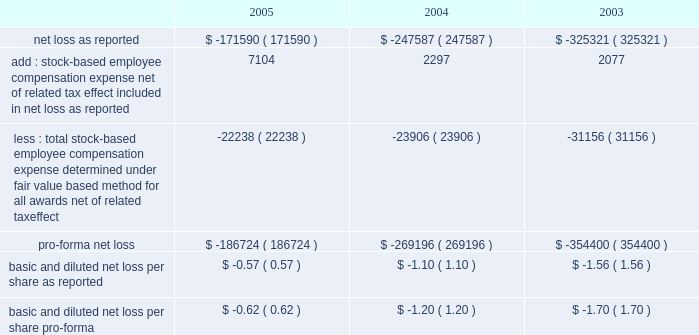American tower corporation and subsidiaries notes to consolidated financial statements 2014 ( continued ) sfas no .
148 .
In accordance with apb no .
25 , the company recognizes compensation expense based on the excess , if any , of the quoted stock price at the grant date of the award or other measurement date over the amount an employee must pay to acquire the stock .
The company 2019s stock option plans are more fully described in note 14 .
In december 2004 , the fasb issued sfas no .
123 ( revised 2004 ) , 201cshare-based payment 201d ( sfas 123r ) , as further described below .
During the year ended december 31 , 2005 , the company reevaluated the assumptions used to estimate the fair value of stock options issued to employees .
As a result , the company lowered its expected volatility assumption for options granted after july 1 , 2005 to approximately 30% ( 30 % ) and increased the expected life of option grants to 6.25 years using the simplified method permitted by sec sab no .
107 , 201dshare-based payment 201d ( sab no .
107 ) .
The company made this change based on a number of factors , including the company 2019s execution of its strategic plans to sell non-core businesses , reduce leverage and refinance its debt , and its recent merger with spectrasite , inc .
( see note 2. ) management had previously based its volatility assumptions on historical volatility since inception , which included periods when the company 2019s capital structure was more highly leveraged than current levels and expected levels for the foreseeable future .
Management 2019s estimate of future volatility is based on its consideration of all available information , including historical volatility , implied volatility of publicly traded options , the company 2019s current capital structure and its publicly announced future business plans .
For comparative purposes , a 10% ( 10 % ) change in the volatility assumption would change pro forma stock option expense and pro forma net loss by approximately $ 0.1 million for the year ended december 31 , 2005 .
( see note 14. ) the table illustrates the effect on net loss and net loss per common share if the company had applied the fair value recognition provisions of sfas no .
123 ( as amended ) to stock-based compensation .
The estimated fair value of each option is calculated using the black-scholes option-pricing model ( in thousands , except per share amounts ) : .
The company has modified certain option awards to revise vesting and exercise terms for certain terminated employees and recognized charges of $ 7.0 million , $ 3.0 million and $ 2.3 million for the years ended december 31 , 2005 , 2004 and 2003 , respectively .
In addition , the stock-based employee compensation amounts above for the year ended december 31 , 2005 , include approximately $ 2.4 million of unearned compensation amortization related to unvested stock options assumed in the merger with spectrasite , inc .
Such charges are reflected in impairments , net loss on sale of long-lived assets , restructuring and merger related expense with corresponding adjustments to additional paid-in capital and unearned compensation in the accompanying consolidated financial statements .
Recent accounting pronouncements 2014in december 2004 , the fasb issued sfas 123r , which supersedes apb no .
25 , and amends sfas no .
95 , 201cstatement of cash flows . 201d this statement addressed the accounting for share-based payments to employees , including grants of employee stock options .
Under the new standard .
What is the total number of outstanding shares as of december 31 , 2005 according to pro-forma income , in millions? 
Computations: (((186724 * 1000) / 0.62) / 1000000)
Answer: 301.16774. 